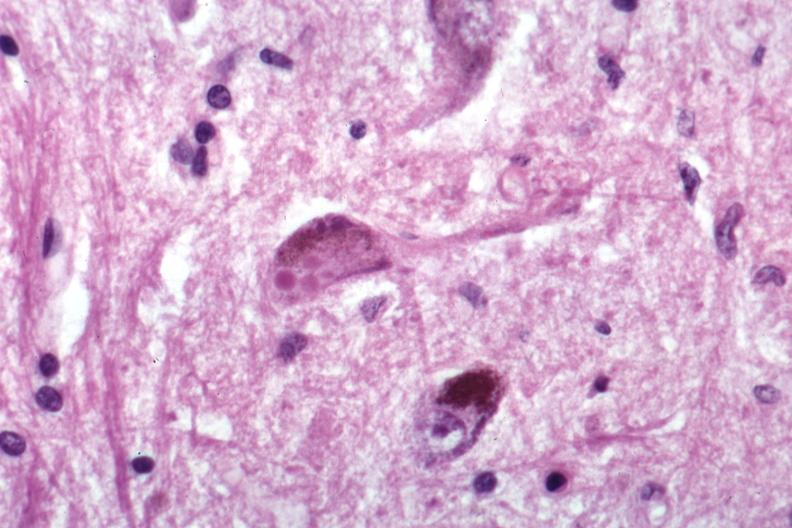s adrenal present?
Answer the question using a single word or phrase. No 